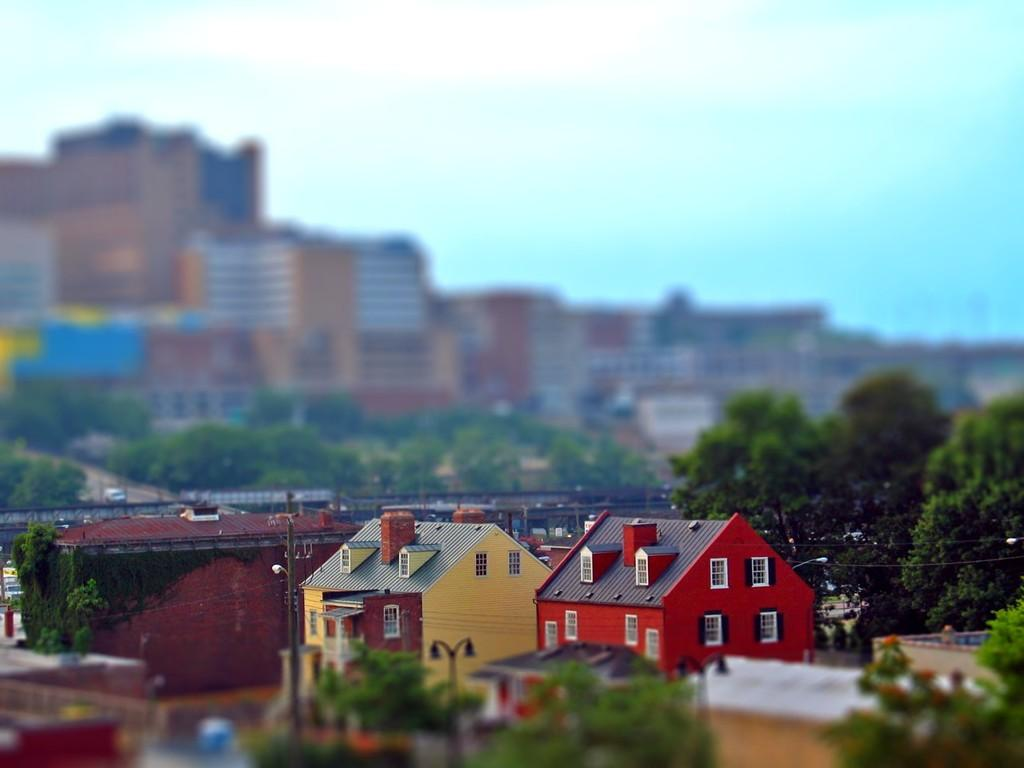What type of structures can be seen in the image? There are houses and buildings in the image. What natural elements are present in the image? There are trees in the image. What part of the natural environment is visible in the image? The sky is visible in the image. How is the background of the image depicted? The background of the image is blurred. How many lizards can be seen climbing on the houses in the image? There are no lizards present in the image; it features houses, buildings, trees, and a blurred background. 